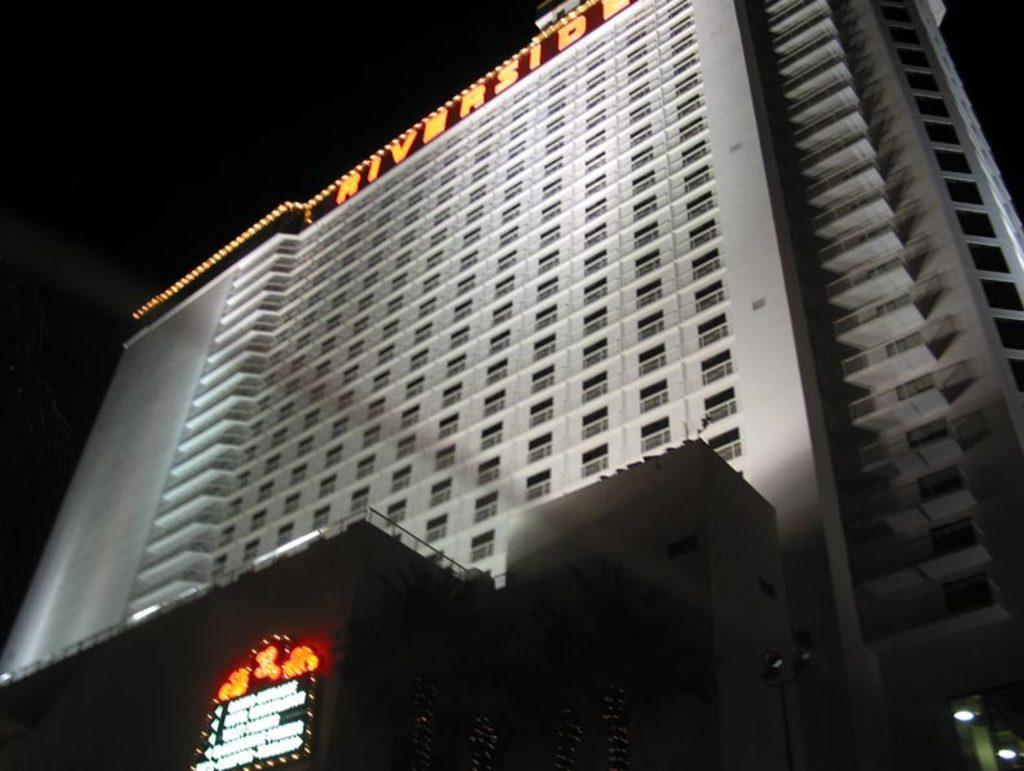What type of structure is visible in the image? There is a building in the image. What can be seen illuminating the building in the image? There are lights in the image. Is there any signage visible on the building? Yes, there is a name board in the image. What type of material is used for the windows of the building? There are glass windows in the image. Can you describe any other objects present in the image? There are other objects in the image, but their specific details are not mentioned in the provided facts. How would you describe the overall lighting condition in the image? The background of the image is dark. Can you see a cub playing with a bee in the image? There is no cub or bee present in the image. How does the building stretch out in the image? Buildings do not stretch; they are stationary structures. 